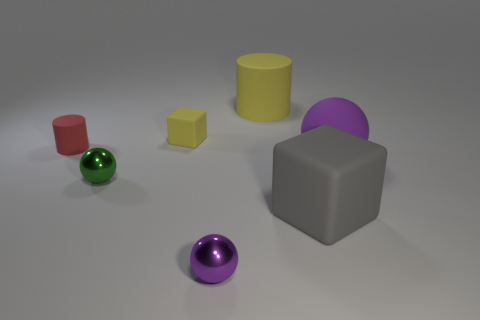Add 1 tiny red rubber cylinders. How many objects exist? 8 Subtract all cubes. How many objects are left? 5 Subtract 1 red cylinders. How many objects are left? 6 Subtract all big brown rubber balls. Subtract all large purple spheres. How many objects are left? 6 Add 7 small metal objects. How many small metal objects are left? 9 Add 4 big rubber objects. How many big rubber objects exist? 7 